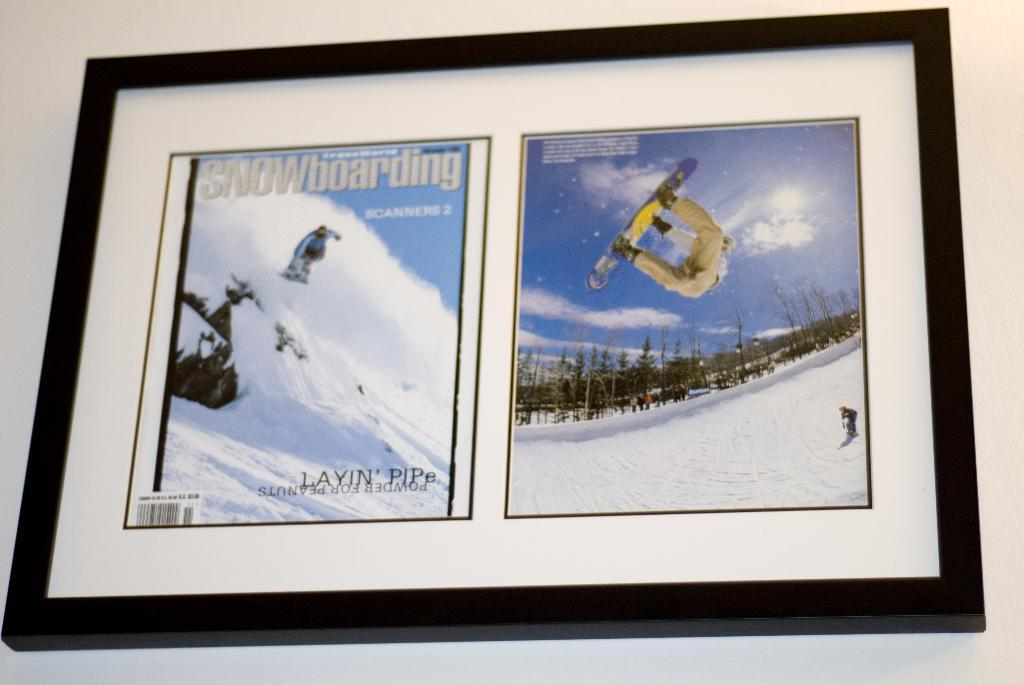<image>
Offer a succinct explanation of the picture presented. Someone framed a copy of Snowboarding magazine, the "Layin' Pipe" issue. 